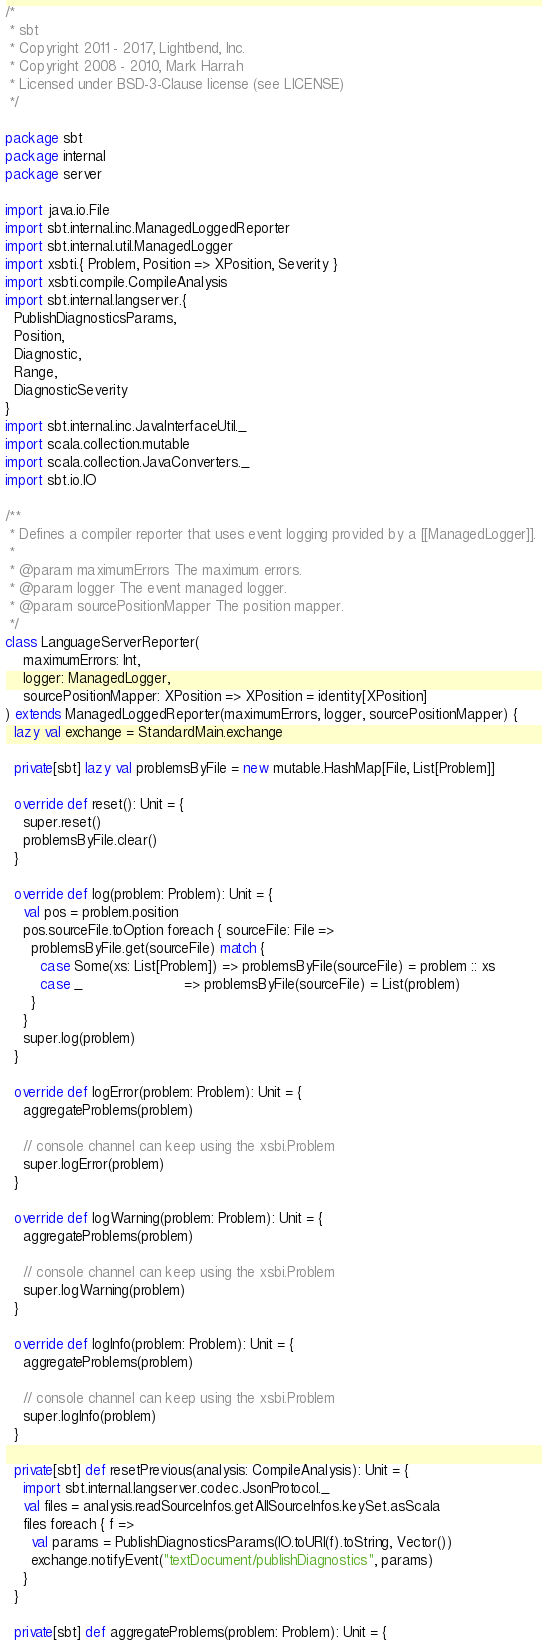<code> <loc_0><loc_0><loc_500><loc_500><_Scala_>/*
 * sbt
 * Copyright 2011 - 2017, Lightbend, Inc.
 * Copyright 2008 - 2010, Mark Harrah
 * Licensed under BSD-3-Clause license (see LICENSE)
 */

package sbt
package internal
package server

import java.io.File
import sbt.internal.inc.ManagedLoggedReporter
import sbt.internal.util.ManagedLogger
import xsbti.{ Problem, Position => XPosition, Severity }
import xsbti.compile.CompileAnalysis
import sbt.internal.langserver.{
  PublishDiagnosticsParams,
  Position,
  Diagnostic,
  Range,
  DiagnosticSeverity
}
import sbt.internal.inc.JavaInterfaceUtil._
import scala.collection.mutable
import scala.collection.JavaConverters._
import sbt.io.IO

/**
 * Defines a compiler reporter that uses event logging provided by a [[ManagedLogger]].
 *
 * @param maximumErrors The maximum errors.
 * @param logger The event managed logger.
 * @param sourcePositionMapper The position mapper.
 */
class LanguageServerReporter(
    maximumErrors: Int,
    logger: ManagedLogger,
    sourcePositionMapper: XPosition => XPosition = identity[XPosition]
) extends ManagedLoggedReporter(maximumErrors, logger, sourcePositionMapper) {
  lazy val exchange = StandardMain.exchange

  private[sbt] lazy val problemsByFile = new mutable.HashMap[File, List[Problem]]

  override def reset(): Unit = {
    super.reset()
    problemsByFile.clear()
  }

  override def log(problem: Problem): Unit = {
    val pos = problem.position
    pos.sourceFile.toOption foreach { sourceFile: File =>
      problemsByFile.get(sourceFile) match {
        case Some(xs: List[Problem]) => problemsByFile(sourceFile) = problem :: xs
        case _                       => problemsByFile(sourceFile) = List(problem)
      }
    }
    super.log(problem)
  }

  override def logError(problem: Problem): Unit = {
    aggregateProblems(problem)

    // console channel can keep using the xsbi.Problem
    super.logError(problem)
  }

  override def logWarning(problem: Problem): Unit = {
    aggregateProblems(problem)

    // console channel can keep using the xsbi.Problem
    super.logWarning(problem)
  }

  override def logInfo(problem: Problem): Unit = {
    aggregateProblems(problem)

    // console channel can keep using the xsbi.Problem
    super.logInfo(problem)
  }

  private[sbt] def resetPrevious(analysis: CompileAnalysis): Unit = {
    import sbt.internal.langserver.codec.JsonProtocol._
    val files = analysis.readSourceInfos.getAllSourceInfos.keySet.asScala
    files foreach { f =>
      val params = PublishDiagnosticsParams(IO.toURI(f).toString, Vector())
      exchange.notifyEvent("textDocument/publishDiagnostics", params)
    }
  }

  private[sbt] def aggregateProblems(problem: Problem): Unit = {</code> 